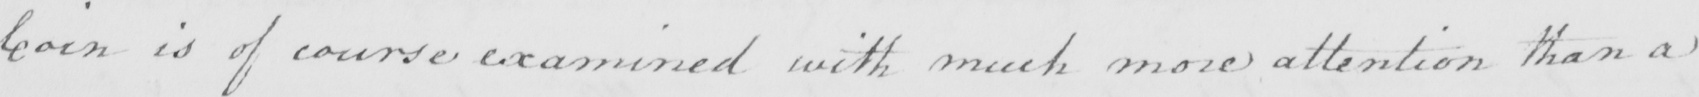What is written in this line of handwriting? Coin is of course examined with much more attention than a 